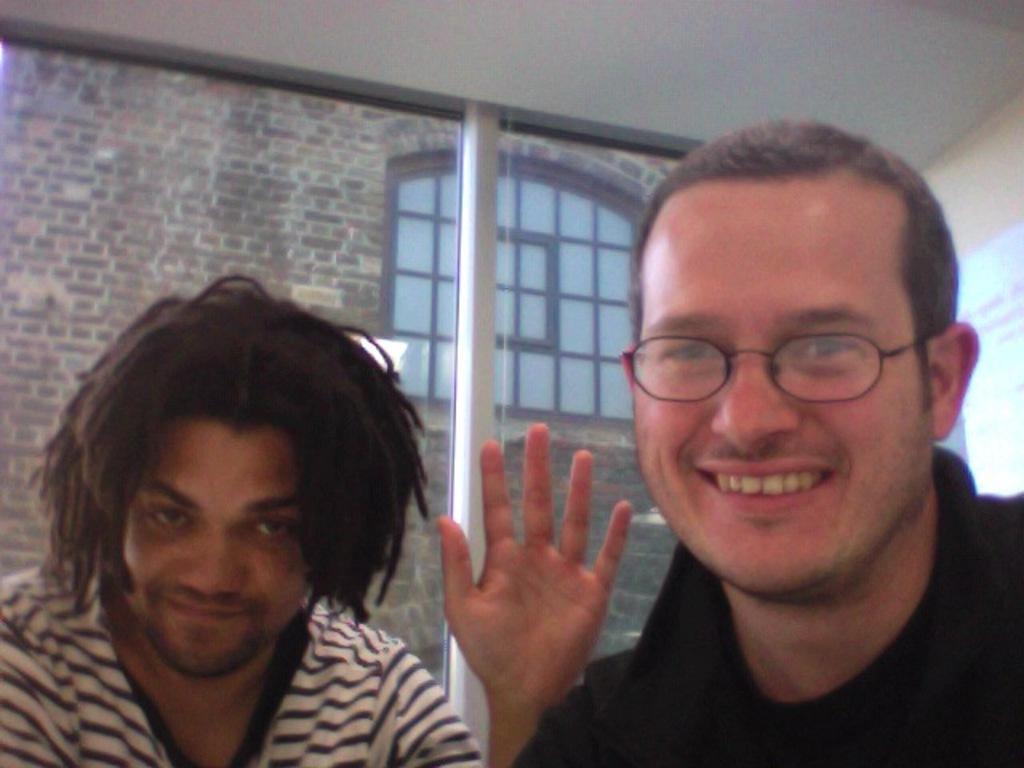Please provide a concise description of this image. In this picture we can see two persons, among them one person is wearing spectacles. 